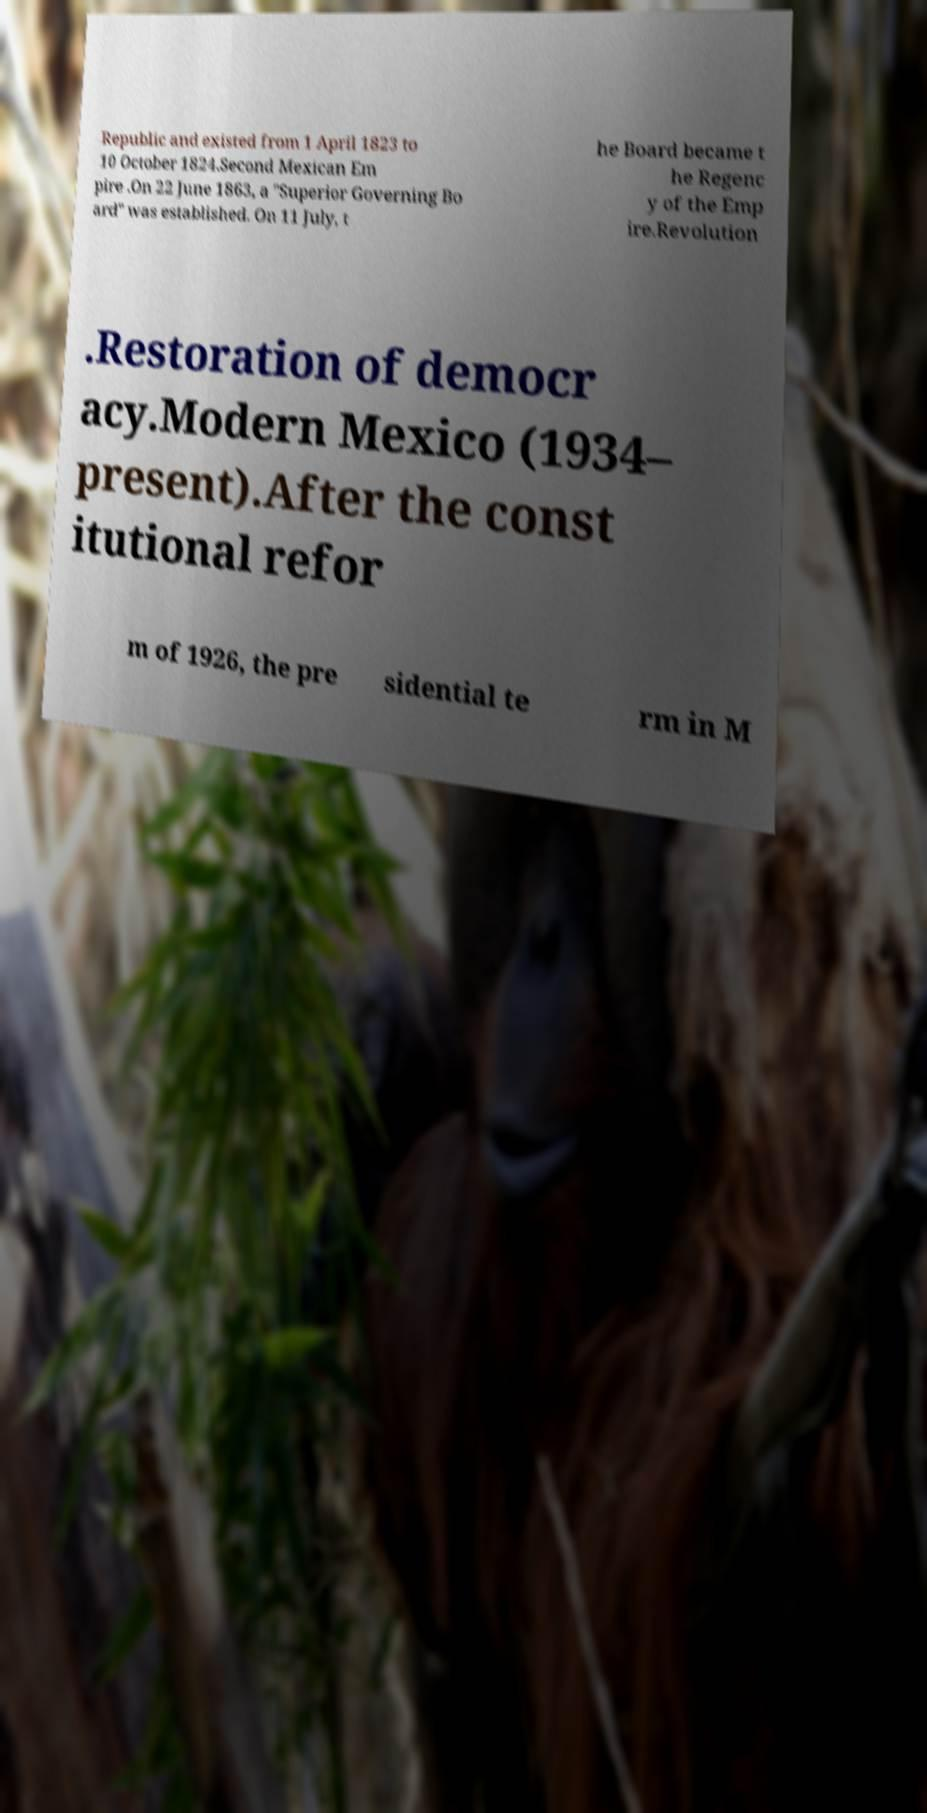I need the written content from this picture converted into text. Can you do that? Republic and existed from 1 April 1823 to 10 October 1824.Second Mexican Em pire .On 22 June 1863, a "Superior Governing Bo ard" was established. On 11 July, t he Board became t he Regenc y of the Emp ire.Revolution .Restoration of democr acy.Modern Mexico (1934– present).After the const itutional refor m of 1926, the pre sidential te rm in M 